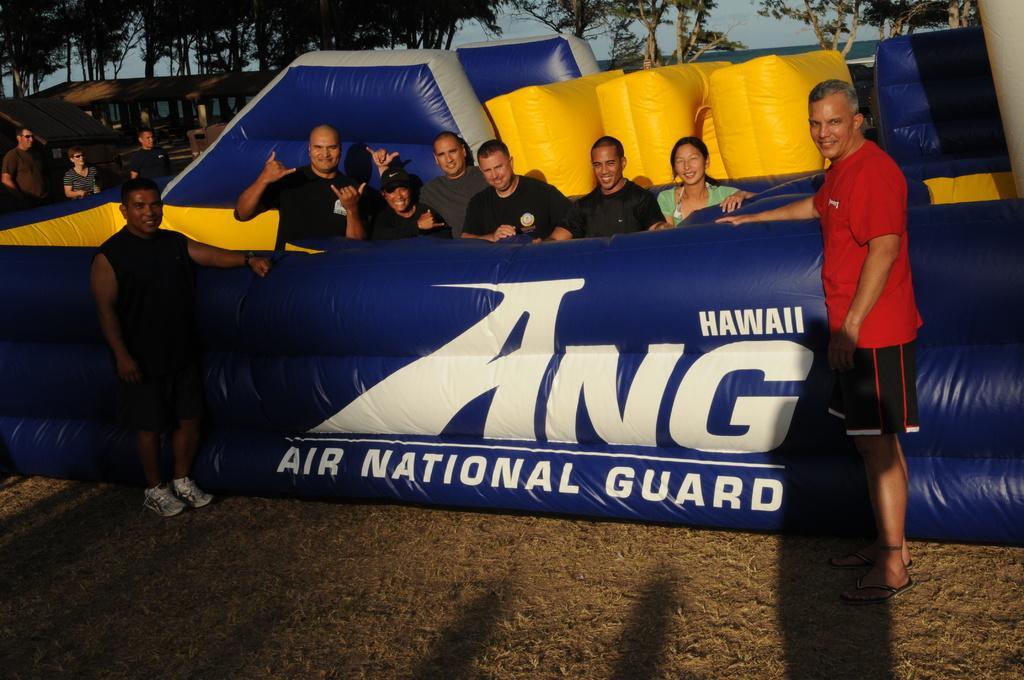Can you describe this image briefly? In the picture I can see a person wearing red color T-shirt is standing on the right side of the image and a person wearing black color T-shirt is standing on the left side of the image and we can see these people are standing in the inflatable object. In the background, we can see a few more people standing, I can see trees and the sky. 